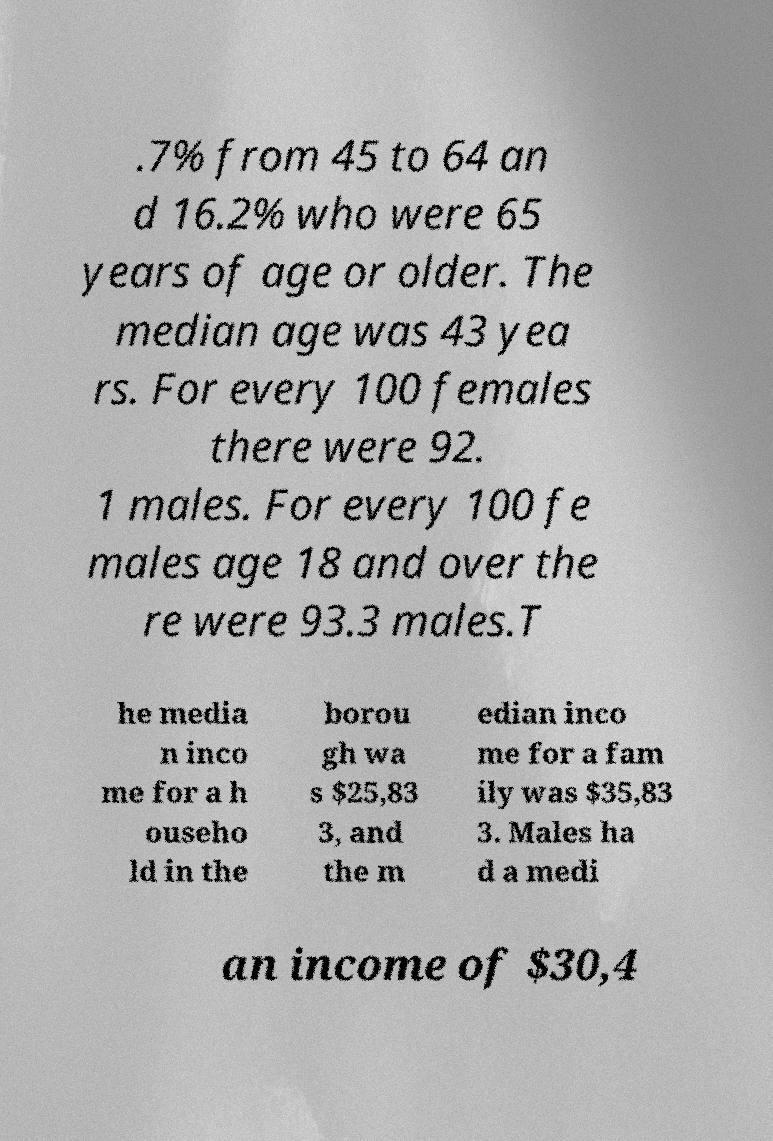Can you accurately transcribe the text from the provided image for me? .7% from 45 to 64 an d 16.2% who were 65 years of age or older. The median age was 43 yea rs. For every 100 females there were 92. 1 males. For every 100 fe males age 18 and over the re were 93.3 males.T he media n inco me for a h ouseho ld in the borou gh wa s $25,83 3, and the m edian inco me for a fam ily was $35,83 3. Males ha d a medi an income of $30,4 